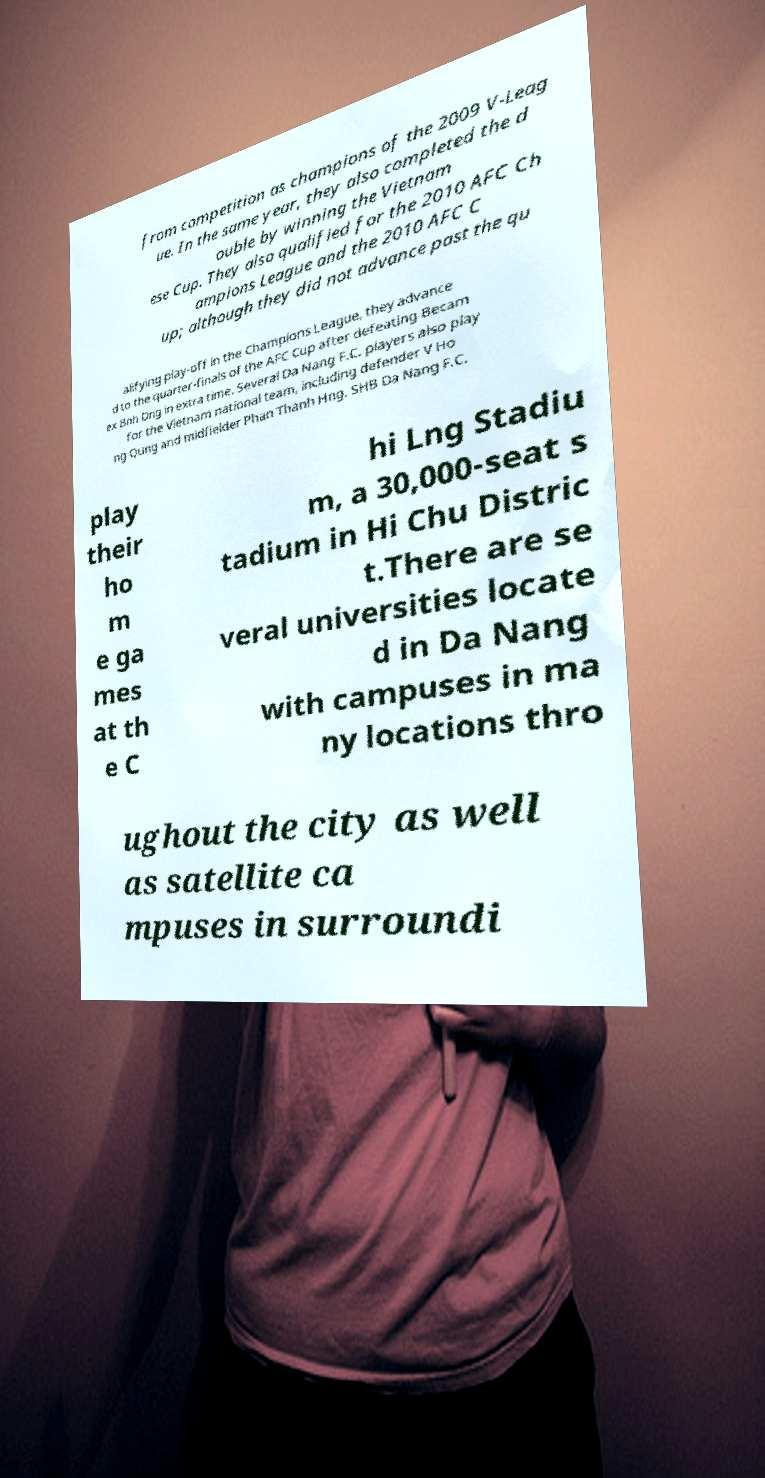Could you extract and type out the text from this image? from competition as champions of the 2009 V-Leag ue. In the same year, they also completed the d ouble by winning the Vietnam ese Cup. They also qualified for the 2010 AFC Ch ampions League and the 2010 AFC C up; although they did not advance past the qu alifying play-off in the Champions League, they advance d to the quarter-finals of the AFC Cup after defeating Becam ex Bnh Dng in extra time. Several Da Nang F.C. players also play for the Vietnam national team, including defender V Ho ng Qung and midfielder Phan Thanh Hng. SHB Da Nang F.C. play their ho m e ga mes at th e C hi Lng Stadiu m, a 30,000-seat s tadium in Hi Chu Distric t.There are se veral universities locate d in Da Nang with campuses in ma ny locations thro ughout the city as well as satellite ca mpuses in surroundi 